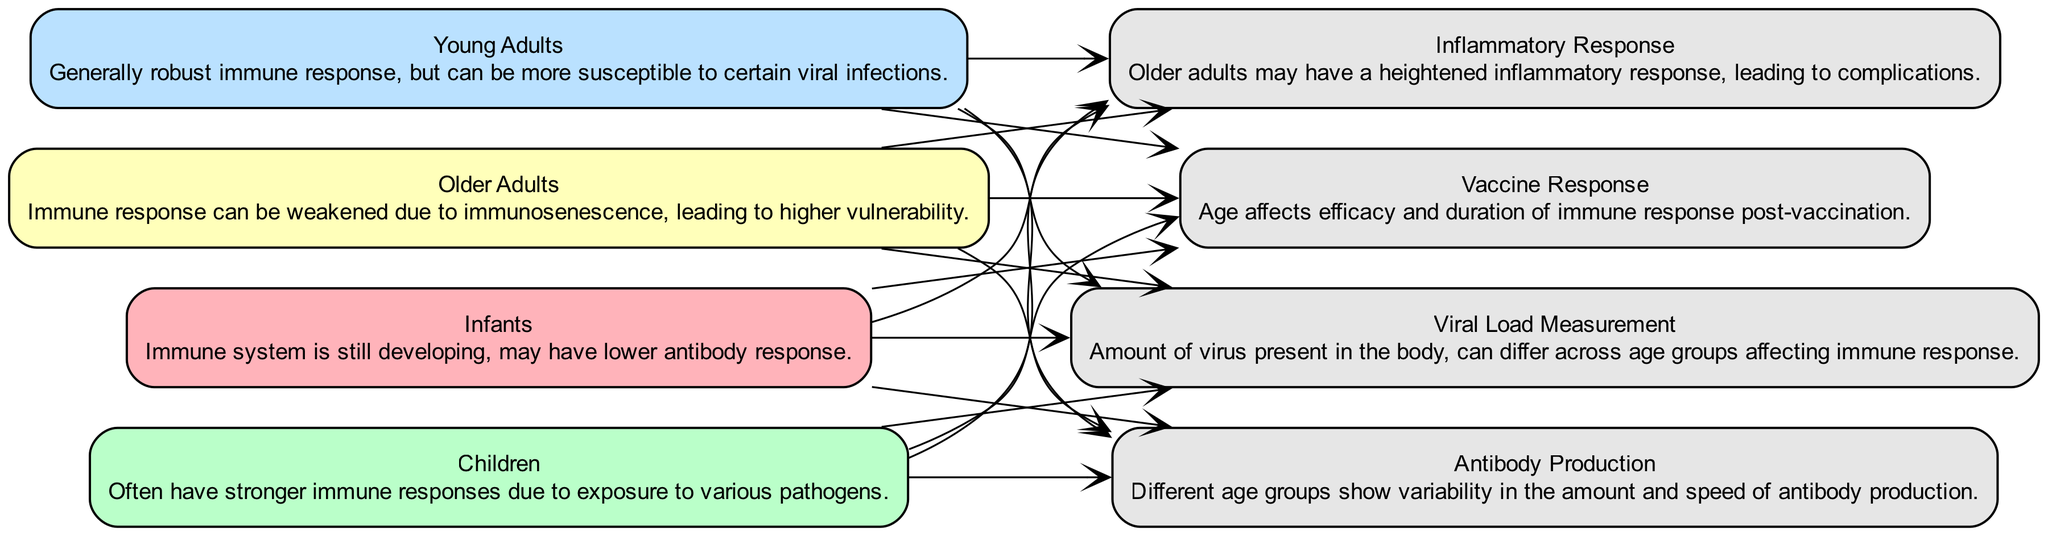What are the four age groups shown in the diagram? The diagram lists "Infants," "Children," "Young Adults," and "Older Adults" as the age groups. Each age group is represented by its node, clearly labeled in the diagram.
Answer: Infants, Children, Young Adults, Older Adults Which age group typically has a lower antibody response? The description for "Infants" states that their immune system is still developing, which may lead to a lower antibody response compared to other age groups.
Answer: Infants What immune response factor is associated with heightened inflammatory response? According to the diagram, "Inflammatory Response" is specifically mentioned in the description for "Older Adults," indicating their susceptibility to complications.
Answer: Inflammatory Response How many unique immune response factors are depicted in the diagram? The diagram lists eight unique immune response factors, as seen in the nodes including "Viral Load Measurement," "Antibody Production," "Inflammatory Response," and "Vaccine Response." Counting them gives a total of eight.
Answer: Eight Which age group is described as having a generally robust immune response? The "Young Adults" node contains the description that they have a generally robust immune response while also noting their susceptibility to certain infections.
Answer: Young Adults Does the diagram indicate that vaccine response efficacy is affected by age? Yes, the "Vaccine Response" node mentions that age affects the efficacy and duration of immune responses, confirming that age is indeed a factor.
Answer: Yes What color represents the "Older Adults" node in the diagram? The diagram uses a light yellow color scheme for "Older Adults," as reflected in the specified color assignment for each age group in the visual representation.
Answer: Light yellow Which age group is mentioned to have stronger immune responses due to pathogen exposure? The description of "Children" states that they often show stronger immune responses due to their exposure to various pathogens over time.
Answer: Children How does the immune response of older adults differ from that of younger age groups? The diagram indicates that older adults may experience weakened immune responses and a heightened inflammatory response, which can increase vulnerabilities compared to younger groups.
Answer: Weakened immune response and heightened inflammatory response 